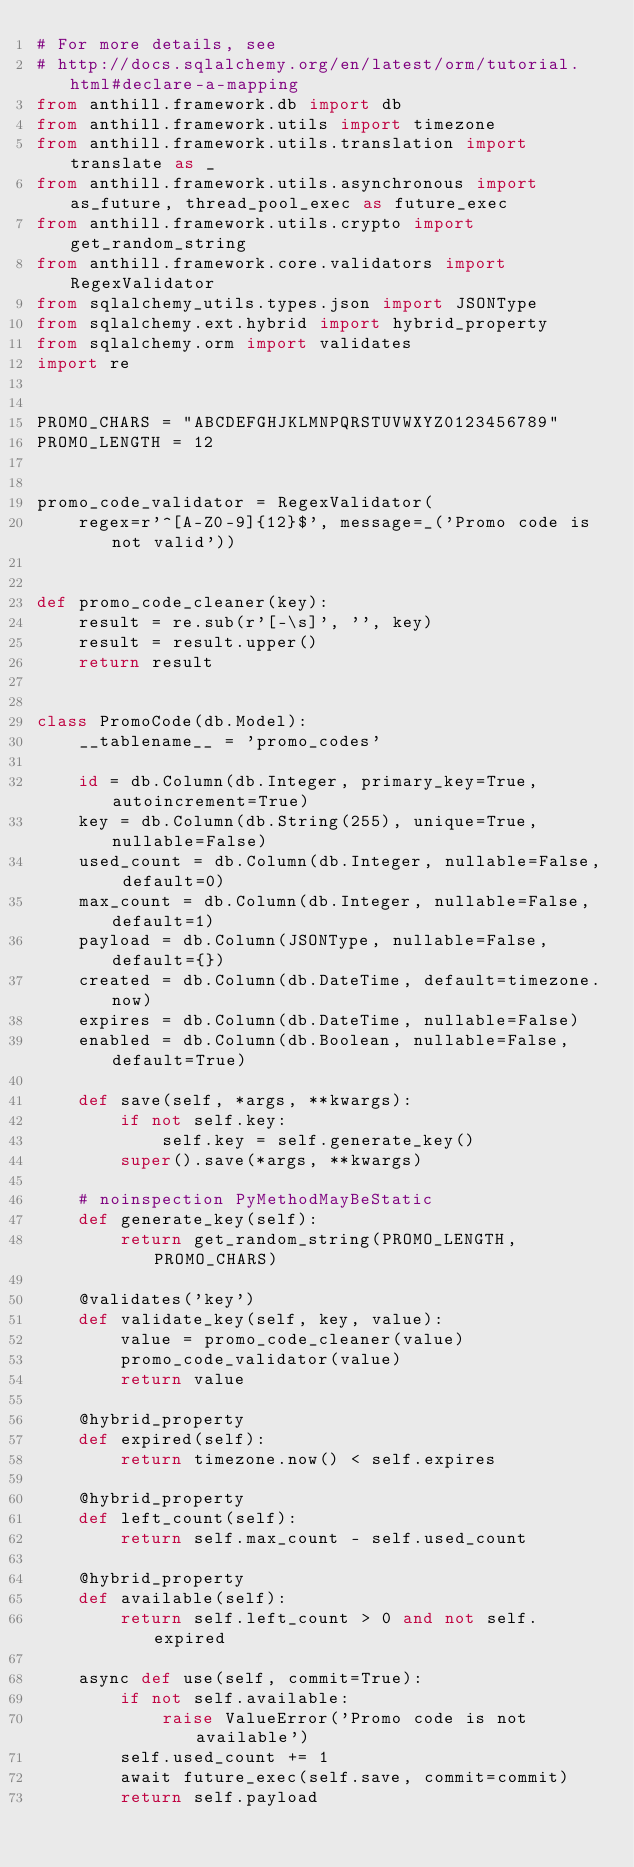<code> <loc_0><loc_0><loc_500><loc_500><_Python_># For more details, see
# http://docs.sqlalchemy.org/en/latest/orm/tutorial.html#declare-a-mapping
from anthill.framework.db import db
from anthill.framework.utils import timezone
from anthill.framework.utils.translation import translate as _
from anthill.framework.utils.asynchronous import as_future, thread_pool_exec as future_exec
from anthill.framework.utils.crypto import get_random_string
from anthill.framework.core.validators import RegexValidator
from sqlalchemy_utils.types.json import JSONType
from sqlalchemy.ext.hybrid import hybrid_property
from sqlalchemy.orm import validates
import re


PROMO_CHARS = "ABCDEFGHJKLMNPQRSTUVWXYZ0123456789"
PROMO_LENGTH = 12


promo_code_validator = RegexValidator(
    regex=r'^[A-Z0-9]{12}$', message=_('Promo code is not valid'))


def promo_code_cleaner(key):
    result = re.sub(r'[-\s]', '', key)
    result = result.upper()
    return result


class PromoCode(db.Model):
    __tablename__ = 'promo_codes'

    id = db.Column(db.Integer, primary_key=True, autoincrement=True)
    key = db.Column(db.String(255), unique=True, nullable=False)
    used_count = db.Column(db.Integer, nullable=False, default=0)
    max_count = db.Column(db.Integer, nullable=False, default=1)
    payload = db.Column(JSONType, nullable=False, default={})
    created = db.Column(db.DateTime, default=timezone.now)
    expires = db.Column(db.DateTime, nullable=False)
    enabled = db.Column(db.Boolean, nullable=False, default=True)

    def save(self, *args, **kwargs):
        if not self.key:
            self.key = self.generate_key()
        super().save(*args, **kwargs)

    # noinspection PyMethodMayBeStatic
    def generate_key(self):
        return get_random_string(PROMO_LENGTH, PROMO_CHARS)

    @validates('key')
    def validate_key(self, key, value):
        value = promo_code_cleaner(value)
        promo_code_validator(value)
        return value

    @hybrid_property
    def expired(self):
        return timezone.now() < self.expires

    @hybrid_property
    def left_count(self):
        return self.max_count - self.used_count

    @hybrid_property
    def available(self):
        return self.left_count > 0 and not self.expired

    async def use(self, commit=True):
        if not self.available:
            raise ValueError('Promo code is not available')
        self.used_count += 1
        await future_exec(self.save, commit=commit)
        return self.payload
</code> 